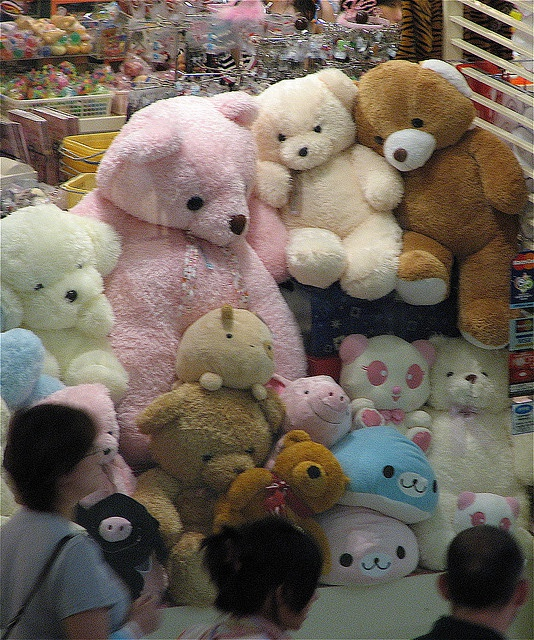Describe the objects in this image and their specific colors. I can see teddy bear in black, darkgray, gray, lightgray, and pink tones, teddy bear in black, maroon, and gray tones, people in black, gray, and blue tones, teddy bear in black, darkgray, lightgray, and tan tones, and teddy bear in black, darkgray, gray, and beige tones in this image. 